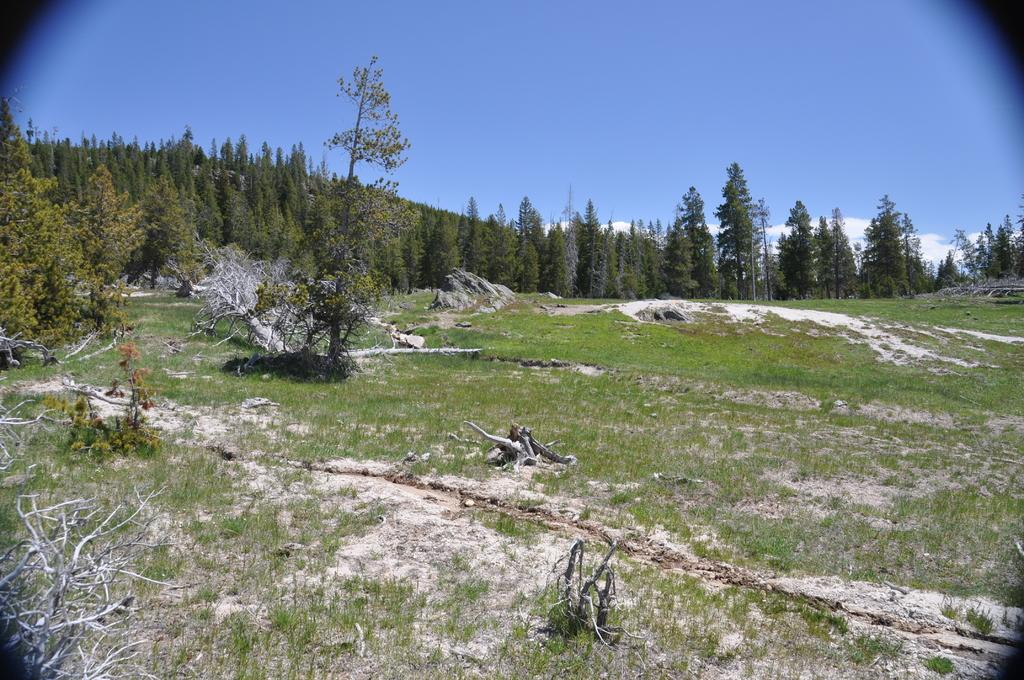What type of vegetation can be seen in the image? There are trees, grass, and plants in the image. What is visible in the background of the image? The sky is visible in the background of the image. What can be seen in the sky? Clouds are present in the sky. What type of fork can be seen in the image? There is no fork present in the image. What kind of test is being conducted in the image? There is no test being conducted in the image; it features trees, grass, plants, and a sky with clouds. 